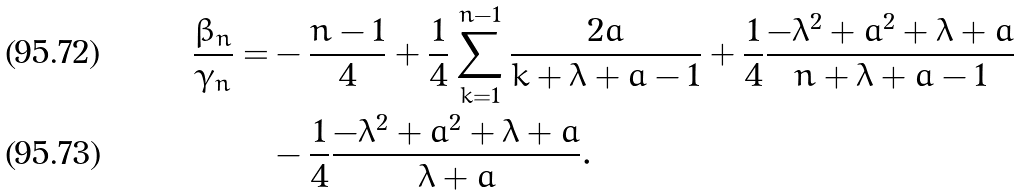<formula> <loc_0><loc_0><loc_500><loc_500>\frac { \beta _ { n } } { \gamma _ { n } } = & - \frac { n - 1 } { 4 } + \frac { 1 } { 4 } \sum _ { k = 1 } ^ { n - 1 } \frac { 2 a } { k + \lambda + a - 1 } + \frac { 1 } { 4 } \frac { - \lambda ^ { 2 } + a ^ { 2 } + \lambda + a } { n + \lambda + a - 1 } \\ & - \frac { 1 } { 4 } \frac { - \lambda ^ { 2 } + a ^ { 2 } + \lambda + a } { \lambda + a } .</formula> 